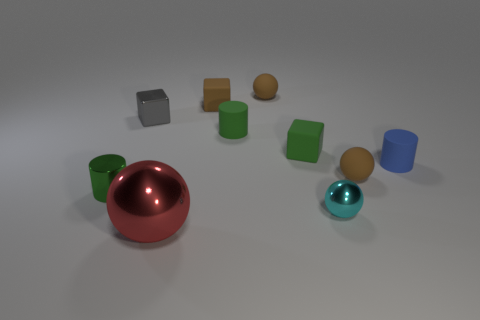Subtract all blue matte cylinders. How many cylinders are left? 2 Subtract all cylinders. How many objects are left? 7 Subtract all gray blocks. How many blocks are left? 2 Subtract all yellow cubes. How many brown balls are left? 2 Subtract 3 cylinders. How many cylinders are left? 0 Subtract all gray balls. Subtract all purple blocks. How many balls are left? 4 Subtract all small cyan cylinders. Subtract all large red metallic things. How many objects are left? 9 Add 4 small cubes. How many small cubes are left? 7 Add 5 tiny blue rubber cubes. How many tiny blue rubber cubes exist? 5 Subtract 0 blue cubes. How many objects are left? 10 